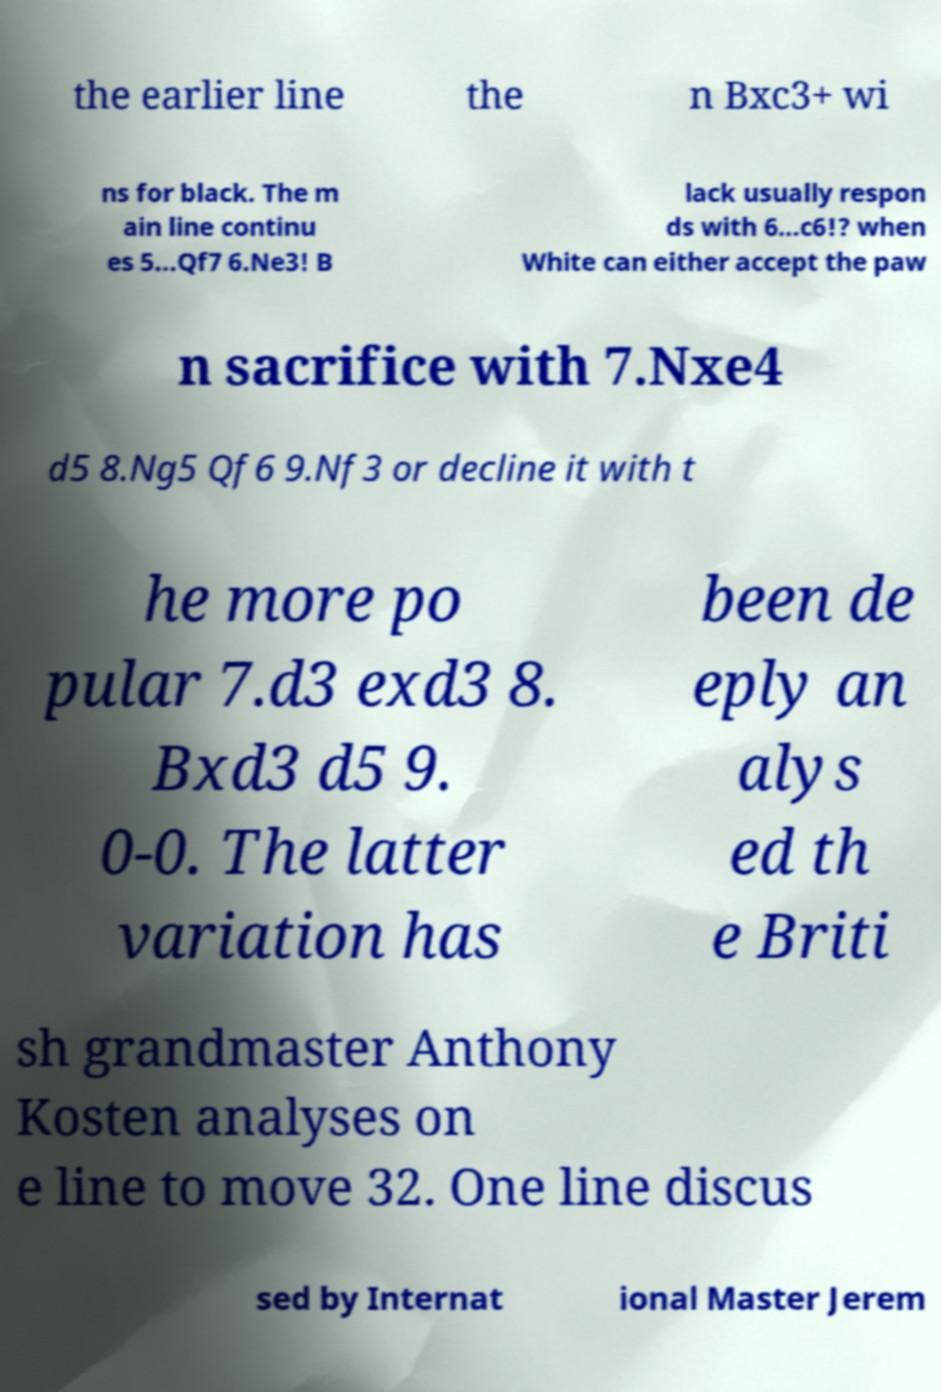For documentation purposes, I need the text within this image transcribed. Could you provide that? the earlier line the n Bxc3+ wi ns for black. The m ain line continu es 5...Qf7 6.Ne3! B lack usually respon ds with 6...c6!? when White can either accept the paw n sacrifice with 7.Nxe4 d5 8.Ng5 Qf6 9.Nf3 or decline it with t he more po pular 7.d3 exd3 8. Bxd3 d5 9. 0-0. The latter variation has been de eply an alys ed th e Briti sh grandmaster Anthony Kosten analyses on e line to move 32. One line discus sed by Internat ional Master Jerem 